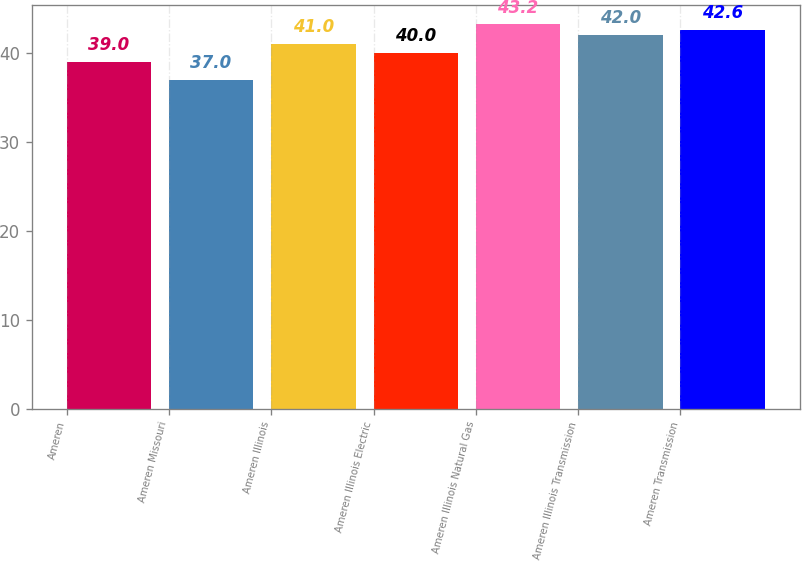<chart> <loc_0><loc_0><loc_500><loc_500><bar_chart><fcel>Ameren<fcel>Ameren Missouri<fcel>Ameren Illinois<fcel>Ameren Illinois Electric<fcel>Ameren Illinois Natural Gas<fcel>Ameren Illinois Transmission<fcel>Ameren Transmission<nl><fcel>39<fcel>37<fcel>41<fcel>40<fcel>43.2<fcel>42<fcel>42.6<nl></chart> 